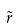Convert formula to latex. <formula><loc_0><loc_0><loc_500><loc_500>\tilde { r }</formula> 